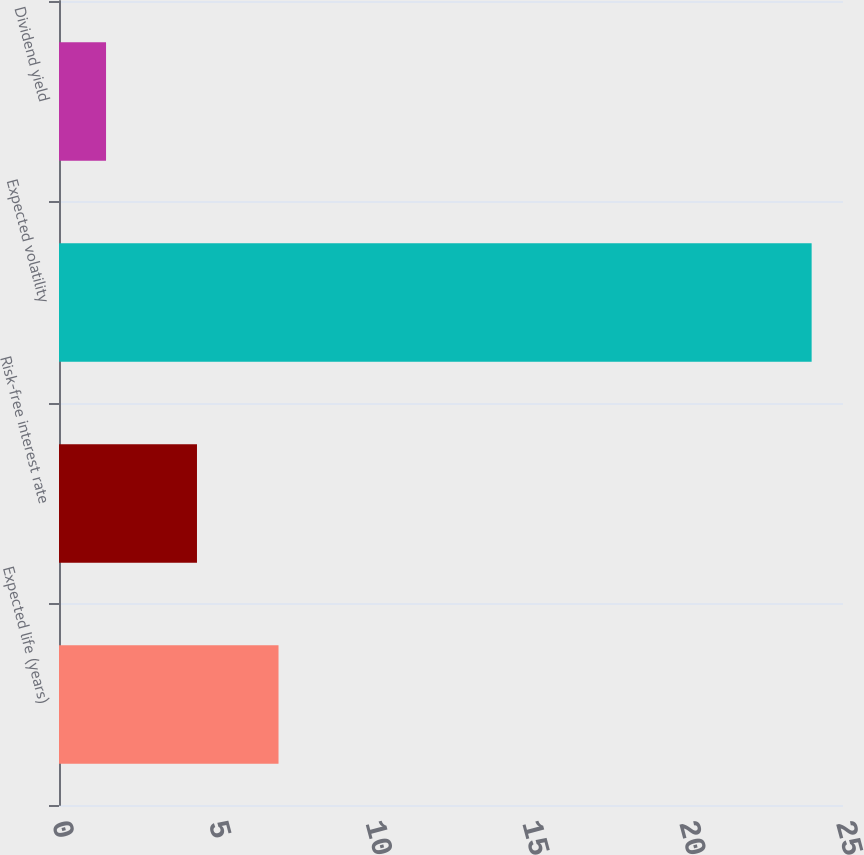Convert chart. <chart><loc_0><loc_0><loc_500><loc_500><bar_chart><fcel>Expected life (years)<fcel>Risk-free interest rate<fcel>Expected volatility<fcel>Dividend yield<nl><fcel>7<fcel>4.4<fcel>24<fcel>1.5<nl></chart> 